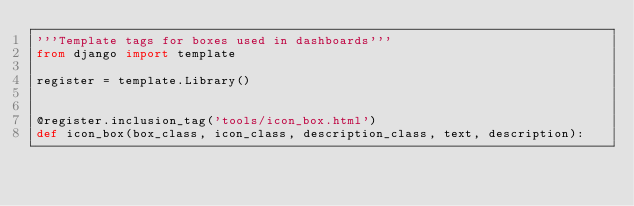Convert code to text. <code><loc_0><loc_0><loc_500><loc_500><_Python_>'''Template tags for boxes used in dashboards'''
from django import template

register = template.Library()


@register.inclusion_tag('tools/icon_box.html')
def icon_box(box_class, icon_class, description_class, text, description):</code> 